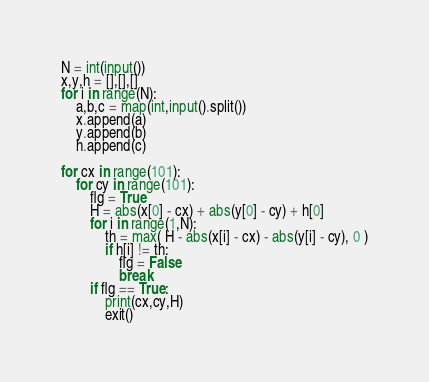Convert code to text. <code><loc_0><loc_0><loc_500><loc_500><_Python_>N = int(input())
x,y,h = [],[],[]
for i in range(N):
    a,b,c = map(int,input().split())
    x.append(a)
    y.append(b)
    h.append(c)

for cx in range(101):
    for cy in range(101):
        flg = True
        H = abs(x[0] - cx) + abs(y[0] - cy) + h[0]
        for i in range(1,N):
            th = max( H - abs(x[i] - cx) - abs(y[i] - cy), 0 )
            if h[i] != th:
                flg = False
                break
        if flg == True:
            print(cx,cy,H)
            exit()
</code> 